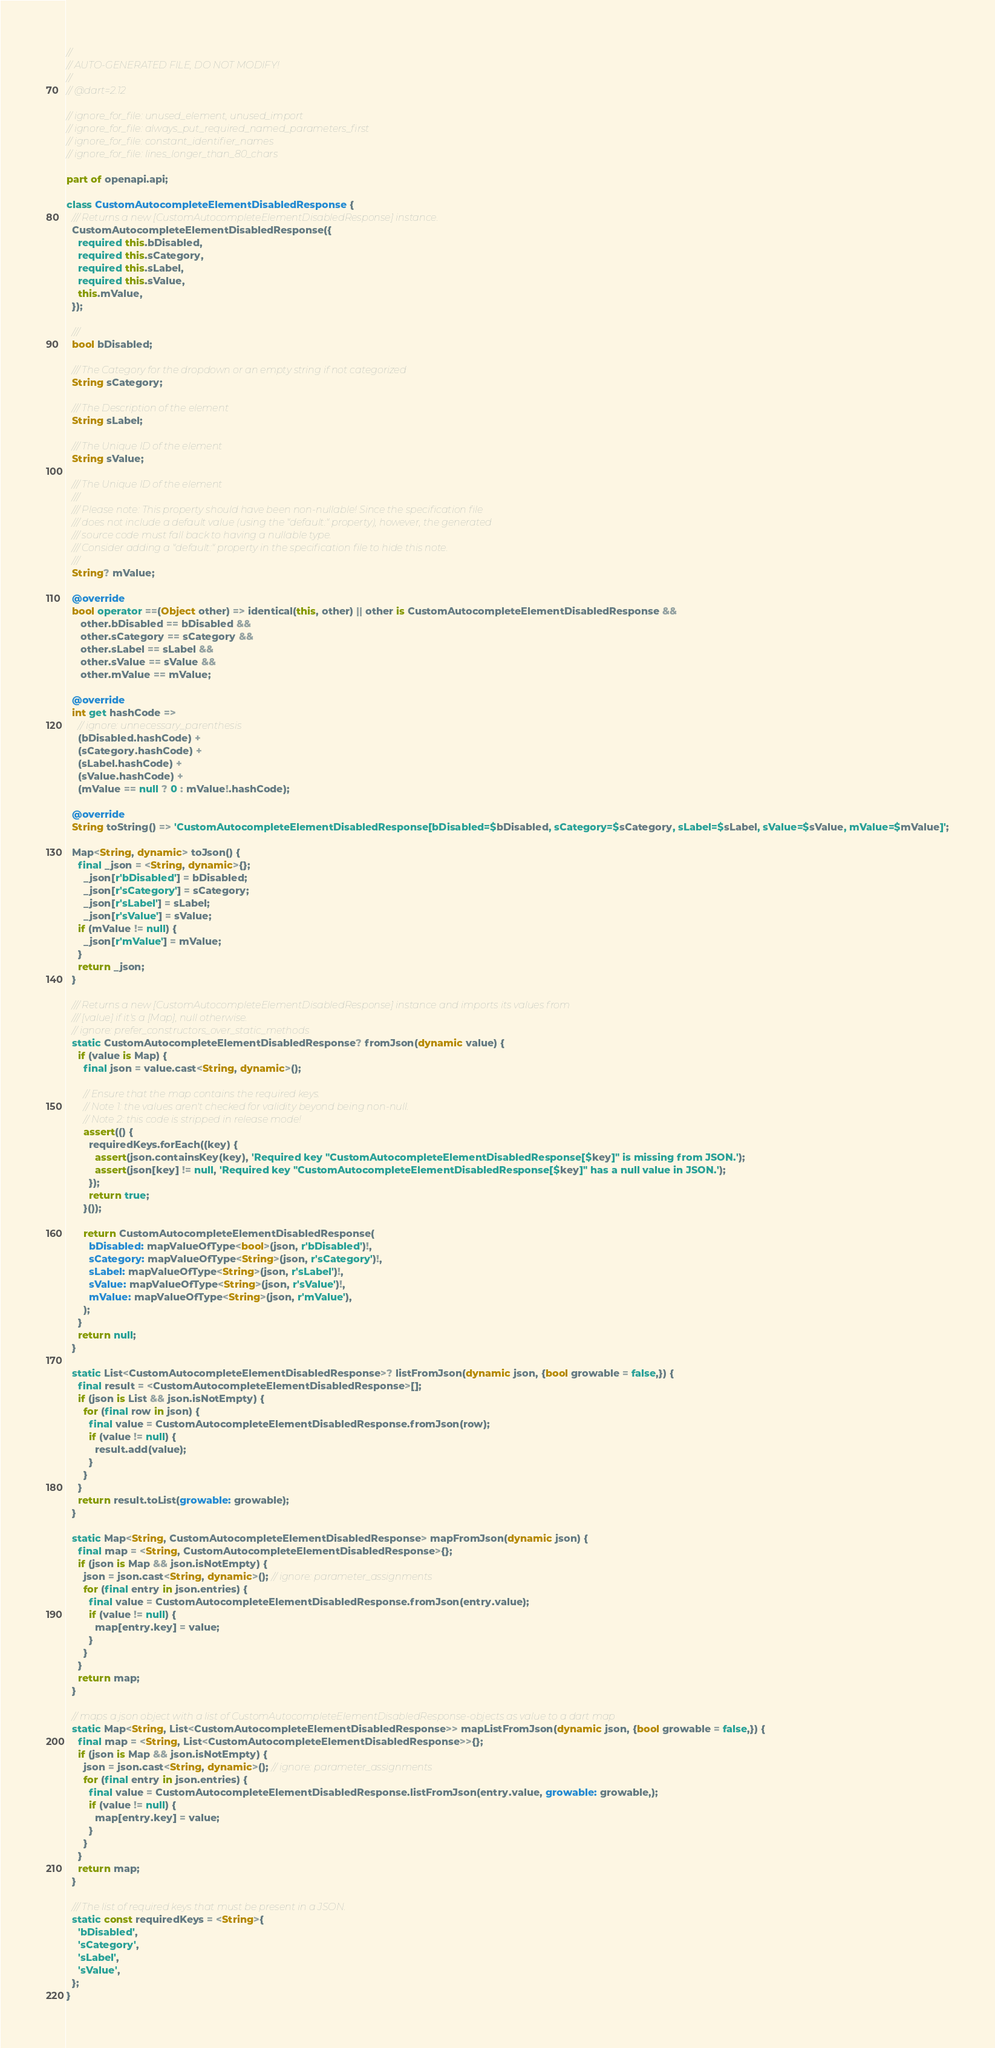<code> <loc_0><loc_0><loc_500><loc_500><_Dart_>//
// AUTO-GENERATED FILE, DO NOT MODIFY!
//
// @dart=2.12

// ignore_for_file: unused_element, unused_import
// ignore_for_file: always_put_required_named_parameters_first
// ignore_for_file: constant_identifier_names
// ignore_for_file: lines_longer_than_80_chars

part of openapi.api;

class CustomAutocompleteElementDisabledResponse {
  /// Returns a new [CustomAutocompleteElementDisabledResponse] instance.
  CustomAutocompleteElementDisabledResponse({
    required this.bDisabled,
    required this.sCategory,
    required this.sLabel,
    required this.sValue,
    this.mValue,
  });

  /// 
  bool bDisabled;

  /// The Category for the dropdown or an empty string if not categorized
  String sCategory;

  /// The Description of the element
  String sLabel;

  /// The Unique ID of the element
  String sValue;

  /// The Unique ID of the element
  ///
  /// Please note: This property should have been non-nullable! Since the specification file
  /// does not include a default value (using the "default:" property), however, the generated
  /// source code must fall back to having a nullable type.
  /// Consider adding a "default:" property in the specification file to hide this note.
  ///
  String? mValue;

  @override
  bool operator ==(Object other) => identical(this, other) || other is CustomAutocompleteElementDisabledResponse &&
     other.bDisabled == bDisabled &&
     other.sCategory == sCategory &&
     other.sLabel == sLabel &&
     other.sValue == sValue &&
     other.mValue == mValue;

  @override
  int get hashCode =>
    // ignore: unnecessary_parenthesis
    (bDisabled.hashCode) +
    (sCategory.hashCode) +
    (sLabel.hashCode) +
    (sValue.hashCode) +
    (mValue == null ? 0 : mValue!.hashCode);

  @override
  String toString() => 'CustomAutocompleteElementDisabledResponse[bDisabled=$bDisabled, sCategory=$sCategory, sLabel=$sLabel, sValue=$sValue, mValue=$mValue]';

  Map<String, dynamic> toJson() {
    final _json = <String, dynamic>{};
      _json[r'bDisabled'] = bDisabled;
      _json[r'sCategory'] = sCategory;
      _json[r'sLabel'] = sLabel;
      _json[r'sValue'] = sValue;
    if (mValue != null) {
      _json[r'mValue'] = mValue;
    }
    return _json;
  }

  /// Returns a new [CustomAutocompleteElementDisabledResponse] instance and imports its values from
  /// [value] if it's a [Map], null otherwise.
  // ignore: prefer_constructors_over_static_methods
  static CustomAutocompleteElementDisabledResponse? fromJson(dynamic value) {
    if (value is Map) {
      final json = value.cast<String, dynamic>();

      // Ensure that the map contains the required keys.
      // Note 1: the values aren't checked for validity beyond being non-null.
      // Note 2: this code is stripped in release mode!
      assert(() {
        requiredKeys.forEach((key) {
          assert(json.containsKey(key), 'Required key "CustomAutocompleteElementDisabledResponse[$key]" is missing from JSON.');
          assert(json[key] != null, 'Required key "CustomAutocompleteElementDisabledResponse[$key]" has a null value in JSON.');
        });
        return true;
      }());

      return CustomAutocompleteElementDisabledResponse(
        bDisabled: mapValueOfType<bool>(json, r'bDisabled')!,
        sCategory: mapValueOfType<String>(json, r'sCategory')!,
        sLabel: mapValueOfType<String>(json, r'sLabel')!,
        sValue: mapValueOfType<String>(json, r'sValue')!,
        mValue: mapValueOfType<String>(json, r'mValue'),
      );
    }
    return null;
  }

  static List<CustomAutocompleteElementDisabledResponse>? listFromJson(dynamic json, {bool growable = false,}) {
    final result = <CustomAutocompleteElementDisabledResponse>[];
    if (json is List && json.isNotEmpty) {
      for (final row in json) {
        final value = CustomAutocompleteElementDisabledResponse.fromJson(row);
        if (value != null) {
          result.add(value);
        }
      }
    }
    return result.toList(growable: growable);
  }

  static Map<String, CustomAutocompleteElementDisabledResponse> mapFromJson(dynamic json) {
    final map = <String, CustomAutocompleteElementDisabledResponse>{};
    if (json is Map && json.isNotEmpty) {
      json = json.cast<String, dynamic>(); // ignore: parameter_assignments
      for (final entry in json.entries) {
        final value = CustomAutocompleteElementDisabledResponse.fromJson(entry.value);
        if (value != null) {
          map[entry.key] = value;
        }
      }
    }
    return map;
  }

  // maps a json object with a list of CustomAutocompleteElementDisabledResponse-objects as value to a dart map
  static Map<String, List<CustomAutocompleteElementDisabledResponse>> mapListFromJson(dynamic json, {bool growable = false,}) {
    final map = <String, List<CustomAutocompleteElementDisabledResponse>>{};
    if (json is Map && json.isNotEmpty) {
      json = json.cast<String, dynamic>(); // ignore: parameter_assignments
      for (final entry in json.entries) {
        final value = CustomAutocompleteElementDisabledResponse.listFromJson(entry.value, growable: growable,);
        if (value != null) {
          map[entry.key] = value;
        }
      }
    }
    return map;
  }

  /// The list of required keys that must be present in a JSON.
  static const requiredKeys = <String>{
    'bDisabled',
    'sCategory',
    'sLabel',
    'sValue',
  };
}

</code> 